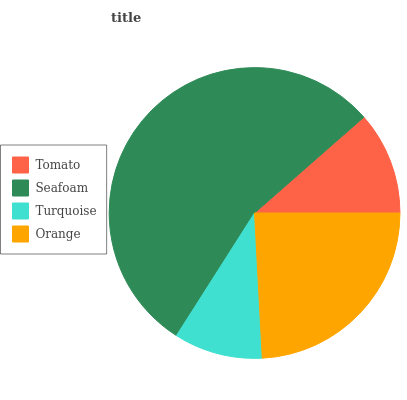Is Turquoise the minimum?
Answer yes or no. Yes. Is Seafoam the maximum?
Answer yes or no. Yes. Is Seafoam the minimum?
Answer yes or no. No. Is Turquoise the maximum?
Answer yes or no. No. Is Seafoam greater than Turquoise?
Answer yes or no. Yes. Is Turquoise less than Seafoam?
Answer yes or no. Yes. Is Turquoise greater than Seafoam?
Answer yes or no. No. Is Seafoam less than Turquoise?
Answer yes or no. No. Is Orange the high median?
Answer yes or no. Yes. Is Tomato the low median?
Answer yes or no. Yes. Is Tomato the high median?
Answer yes or no. No. Is Seafoam the low median?
Answer yes or no. No. 